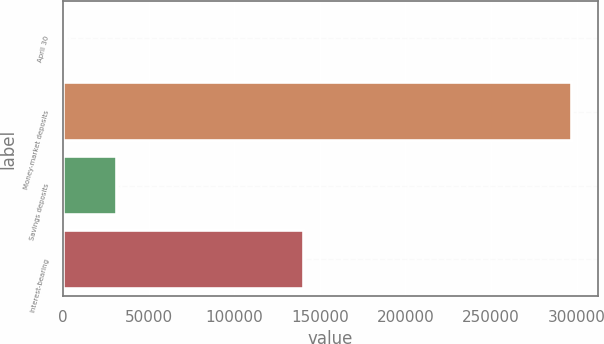<chart> <loc_0><loc_0><loc_500><loc_500><bar_chart><fcel>April 30<fcel>Money-market deposits<fcel>Savings deposits<fcel>Interest-bearing<nl><fcel>2008<fcel>297320<fcel>31539.2<fcel>140529<nl></chart> 